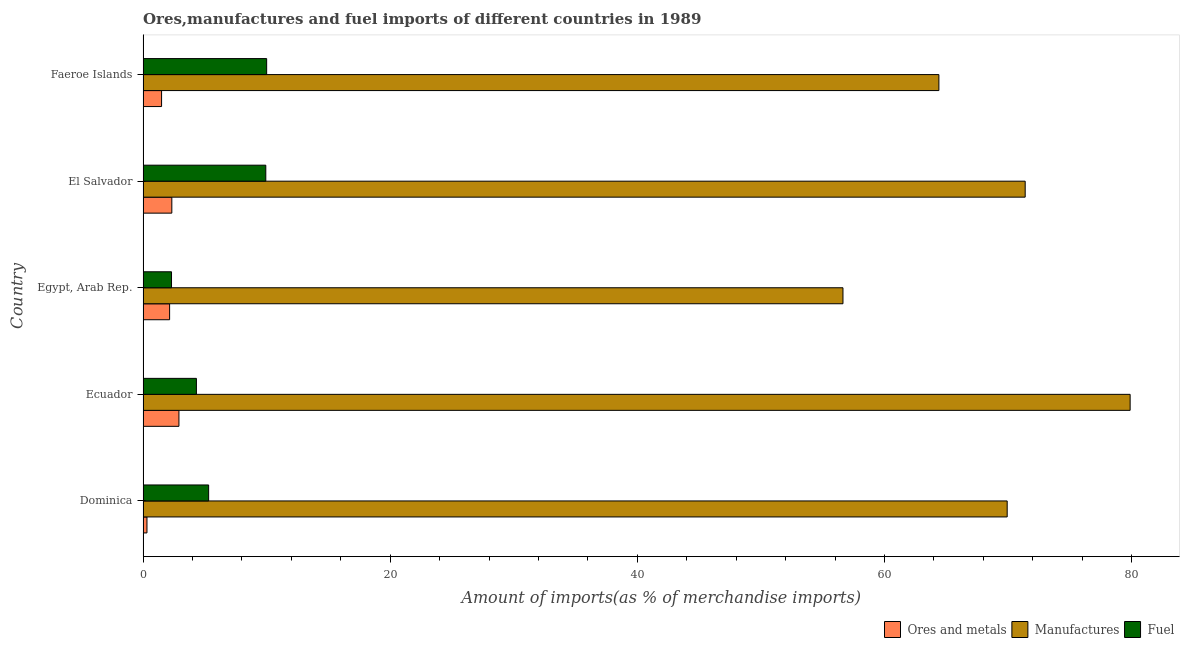Are the number of bars on each tick of the Y-axis equal?
Provide a short and direct response. Yes. How many bars are there on the 5th tick from the bottom?
Keep it short and to the point. 3. What is the label of the 2nd group of bars from the top?
Your answer should be compact. El Salvador. What is the percentage of fuel imports in Dominica?
Offer a terse response. 5.31. Across all countries, what is the maximum percentage of manufactures imports?
Provide a short and direct response. 79.88. Across all countries, what is the minimum percentage of ores and metals imports?
Provide a succinct answer. 0.32. In which country was the percentage of manufactures imports maximum?
Offer a very short reply. Ecuador. In which country was the percentage of ores and metals imports minimum?
Make the answer very short. Dominica. What is the total percentage of fuel imports in the graph?
Offer a terse response. 31.86. What is the difference between the percentage of fuel imports in El Salvador and that in Faeroe Islands?
Your response must be concise. -0.07. What is the difference between the percentage of fuel imports in Ecuador and the percentage of ores and metals imports in Dominica?
Ensure brevity in your answer.  4. What is the average percentage of fuel imports per country?
Your answer should be compact. 6.37. What is the difference between the percentage of ores and metals imports and percentage of fuel imports in Ecuador?
Provide a short and direct response. -1.42. What is the ratio of the percentage of manufactures imports in Dominica to that in Egypt, Arab Rep.?
Ensure brevity in your answer.  1.24. What is the difference between the highest and the second highest percentage of ores and metals imports?
Your answer should be very brief. 0.57. What is the difference between the highest and the lowest percentage of manufactures imports?
Provide a short and direct response. 23.24. What does the 1st bar from the top in El Salvador represents?
Provide a short and direct response. Fuel. What does the 1st bar from the bottom in El Salvador represents?
Offer a very short reply. Ores and metals. Is it the case that in every country, the sum of the percentage of ores and metals imports and percentage of manufactures imports is greater than the percentage of fuel imports?
Ensure brevity in your answer.  Yes. Are all the bars in the graph horizontal?
Offer a very short reply. Yes. How many countries are there in the graph?
Provide a short and direct response. 5. Are the values on the major ticks of X-axis written in scientific E-notation?
Keep it short and to the point. No. Where does the legend appear in the graph?
Your answer should be compact. Bottom right. What is the title of the graph?
Make the answer very short. Ores,manufactures and fuel imports of different countries in 1989. Does "Total employers" appear as one of the legend labels in the graph?
Make the answer very short. No. What is the label or title of the X-axis?
Offer a terse response. Amount of imports(as % of merchandise imports). What is the Amount of imports(as % of merchandise imports) of Ores and metals in Dominica?
Ensure brevity in your answer.  0.32. What is the Amount of imports(as % of merchandise imports) in Manufactures in Dominica?
Your answer should be compact. 69.93. What is the Amount of imports(as % of merchandise imports) in Fuel in Dominica?
Ensure brevity in your answer.  5.31. What is the Amount of imports(as % of merchandise imports) in Ores and metals in Ecuador?
Keep it short and to the point. 2.9. What is the Amount of imports(as % of merchandise imports) in Manufactures in Ecuador?
Your answer should be very brief. 79.88. What is the Amount of imports(as % of merchandise imports) of Fuel in Ecuador?
Your response must be concise. 4.32. What is the Amount of imports(as % of merchandise imports) in Ores and metals in Egypt, Arab Rep.?
Ensure brevity in your answer.  2.15. What is the Amount of imports(as % of merchandise imports) in Manufactures in Egypt, Arab Rep.?
Ensure brevity in your answer.  56.64. What is the Amount of imports(as % of merchandise imports) in Fuel in Egypt, Arab Rep.?
Give a very brief answer. 2.3. What is the Amount of imports(as % of merchandise imports) in Ores and metals in El Salvador?
Keep it short and to the point. 2.33. What is the Amount of imports(as % of merchandise imports) of Manufactures in El Salvador?
Your response must be concise. 71.39. What is the Amount of imports(as % of merchandise imports) of Fuel in El Salvador?
Your answer should be compact. 9.93. What is the Amount of imports(as % of merchandise imports) in Ores and metals in Faeroe Islands?
Make the answer very short. 1.5. What is the Amount of imports(as % of merchandise imports) of Manufactures in Faeroe Islands?
Offer a terse response. 64.41. What is the Amount of imports(as % of merchandise imports) of Fuel in Faeroe Islands?
Provide a short and direct response. 10. Across all countries, what is the maximum Amount of imports(as % of merchandise imports) of Ores and metals?
Your response must be concise. 2.9. Across all countries, what is the maximum Amount of imports(as % of merchandise imports) in Manufactures?
Your response must be concise. 79.88. Across all countries, what is the maximum Amount of imports(as % of merchandise imports) of Fuel?
Offer a very short reply. 10. Across all countries, what is the minimum Amount of imports(as % of merchandise imports) of Ores and metals?
Ensure brevity in your answer.  0.32. Across all countries, what is the minimum Amount of imports(as % of merchandise imports) of Manufactures?
Your answer should be very brief. 56.64. Across all countries, what is the minimum Amount of imports(as % of merchandise imports) in Fuel?
Make the answer very short. 2.3. What is the total Amount of imports(as % of merchandise imports) of Ores and metals in the graph?
Your answer should be compact. 9.19. What is the total Amount of imports(as % of merchandise imports) in Manufactures in the graph?
Offer a terse response. 342.26. What is the total Amount of imports(as % of merchandise imports) of Fuel in the graph?
Give a very brief answer. 31.86. What is the difference between the Amount of imports(as % of merchandise imports) of Ores and metals in Dominica and that in Ecuador?
Your answer should be compact. -2.59. What is the difference between the Amount of imports(as % of merchandise imports) in Manufactures in Dominica and that in Ecuador?
Your answer should be very brief. -9.95. What is the difference between the Amount of imports(as % of merchandise imports) in Ores and metals in Dominica and that in Egypt, Arab Rep.?
Your answer should be compact. -1.83. What is the difference between the Amount of imports(as % of merchandise imports) of Manufactures in Dominica and that in Egypt, Arab Rep.?
Give a very brief answer. 13.29. What is the difference between the Amount of imports(as % of merchandise imports) in Fuel in Dominica and that in Egypt, Arab Rep.?
Provide a short and direct response. 3.01. What is the difference between the Amount of imports(as % of merchandise imports) of Ores and metals in Dominica and that in El Salvador?
Offer a very short reply. -2.01. What is the difference between the Amount of imports(as % of merchandise imports) of Manufactures in Dominica and that in El Salvador?
Make the answer very short. -1.46. What is the difference between the Amount of imports(as % of merchandise imports) of Fuel in Dominica and that in El Salvador?
Your response must be concise. -4.63. What is the difference between the Amount of imports(as % of merchandise imports) of Ores and metals in Dominica and that in Faeroe Islands?
Keep it short and to the point. -1.18. What is the difference between the Amount of imports(as % of merchandise imports) of Manufactures in Dominica and that in Faeroe Islands?
Offer a terse response. 5.53. What is the difference between the Amount of imports(as % of merchandise imports) of Fuel in Dominica and that in Faeroe Islands?
Your answer should be compact. -4.7. What is the difference between the Amount of imports(as % of merchandise imports) in Ores and metals in Ecuador and that in Egypt, Arab Rep.?
Offer a terse response. 0.75. What is the difference between the Amount of imports(as % of merchandise imports) in Manufactures in Ecuador and that in Egypt, Arab Rep.?
Your response must be concise. 23.24. What is the difference between the Amount of imports(as % of merchandise imports) in Fuel in Ecuador and that in Egypt, Arab Rep.?
Your answer should be very brief. 2.02. What is the difference between the Amount of imports(as % of merchandise imports) in Ores and metals in Ecuador and that in El Salvador?
Offer a very short reply. 0.57. What is the difference between the Amount of imports(as % of merchandise imports) of Manufactures in Ecuador and that in El Salvador?
Your answer should be very brief. 8.49. What is the difference between the Amount of imports(as % of merchandise imports) of Fuel in Ecuador and that in El Salvador?
Offer a terse response. -5.62. What is the difference between the Amount of imports(as % of merchandise imports) in Ores and metals in Ecuador and that in Faeroe Islands?
Keep it short and to the point. 1.4. What is the difference between the Amount of imports(as % of merchandise imports) of Manufactures in Ecuador and that in Faeroe Islands?
Your response must be concise. 15.48. What is the difference between the Amount of imports(as % of merchandise imports) in Fuel in Ecuador and that in Faeroe Islands?
Provide a succinct answer. -5.69. What is the difference between the Amount of imports(as % of merchandise imports) in Ores and metals in Egypt, Arab Rep. and that in El Salvador?
Offer a terse response. -0.18. What is the difference between the Amount of imports(as % of merchandise imports) of Manufactures in Egypt, Arab Rep. and that in El Salvador?
Your response must be concise. -14.75. What is the difference between the Amount of imports(as % of merchandise imports) of Fuel in Egypt, Arab Rep. and that in El Salvador?
Provide a short and direct response. -7.63. What is the difference between the Amount of imports(as % of merchandise imports) of Ores and metals in Egypt, Arab Rep. and that in Faeroe Islands?
Keep it short and to the point. 0.65. What is the difference between the Amount of imports(as % of merchandise imports) in Manufactures in Egypt, Arab Rep. and that in Faeroe Islands?
Make the answer very short. -7.76. What is the difference between the Amount of imports(as % of merchandise imports) of Fuel in Egypt, Arab Rep. and that in Faeroe Islands?
Your answer should be compact. -7.7. What is the difference between the Amount of imports(as % of merchandise imports) in Ores and metals in El Salvador and that in Faeroe Islands?
Provide a succinct answer. 0.83. What is the difference between the Amount of imports(as % of merchandise imports) in Manufactures in El Salvador and that in Faeroe Islands?
Provide a succinct answer. 6.98. What is the difference between the Amount of imports(as % of merchandise imports) of Fuel in El Salvador and that in Faeroe Islands?
Keep it short and to the point. -0.07. What is the difference between the Amount of imports(as % of merchandise imports) of Ores and metals in Dominica and the Amount of imports(as % of merchandise imports) of Manufactures in Ecuador?
Keep it short and to the point. -79.57. What is the difference between the Amount of imports(as % of merchandise imports) of Ores and metals in Dominica and the Amount of imports(as % of merchandise imports) of Fuel in Ecuador?
Offer a terse response. -4. What is the difference between the Amount of imports(as % of merchandise imports) of Manufactures in Dominica and the Amount of imports(as % of merchandise imports) of Fuel in Ecuador?
Keep it short and to the point. 65.62. What is the difference between the Amount of imports(as % of merchandise imports) of Ores and metals in Dominica and the Amount of imports(as % of merchandise imports) of Manufactures in Egypt, Arab Rep.?
Keep it short and to the point. -56.33. What is the difference between the Amount of imports(as % of merchandise imports) of Ores and metals in Dominica and the Amount of imports(as % of merchandise imports) of Fuel in Egypt, Arab Rep.?
Offer a very short reply. -1.99. What is the difference between the Amount of imports(as % of merchandise imports) in Manufactures in Dominica and the Amount of imports(as % of merchandise imports) in Fuel in Egypt, Arab Rep.?
Provide a succinct answer. 67.63. What is the difference between the Amount of imports(as % of merchandise imports) of Ores and metals in Dominica and the Amount of imports(as % of merchandise imports) of Manufactures in El Salvador?
Offer a terse response. -71.07. What is the difference between the Amount of imports(as % of merchandise imports) in Ores and metals in Dominica and the Amount of imports(as % of merchandise imports) in Fuel in El Salvador?
Ensure brevity in your answer.  -9.62. What is the difference between the Amount of imports(as % of merchandise imports) of Manufactures in Dominica and the Amount of imports(as % of merchandise imports) of Fuel in El Salvador?
Give a very brief answer. 60. What is the difference between the Amount of imports(as % of merchandise imports) in Ores and metals in Dominica and the Amount of imports(as % of merchandise imports) in Manufactures in Faeroe Islands?
Give a very brief answer. -64.09. What is the difference between the Amount of imports(as % of merchandise imports) of Ores and metals in Dominica and the Amount of imports(as % of merchandise imports) of Fuel in Faeroe Islands?
Your answer should be very brief. -9.69. What is the difference between the Amount of imports(as % of merchandise imports) of Manufactures in Dominica and the Amount of imports(as % of merchandise imports) of Fuel in Faeroe Islands?
Give a very brief answer. 59.93. What is the difference between the Amount of imports(as % of merchandise imports) of Ores and metals in Ecuador and the Amount of imports(as % of merchandise imports) of Manufactures in Egypt, Arab Rep.?
Keep it short and to the point. -53.74. What is the difference between the Amount of imports(as % of merchandise imports) of Ores and metals in Ecuador and the Amount of imports(as % of merchandise imports) of Fuel in Egypt, Arab Rep.?
Keep it short and to the point. 0.6. What is the difference between the Amount of imports(as % of merchandise imports) in Manufactures in Ecuador and the Amount of imports(as % of merchandise imports) in Fuel in Egypt, Arab Rep.?
Give a very brief answer. 77.58. What is the difference between the Amount of imports(as % of merchandise imports) in Ores and metals in Ecuador and the Amount of imports(as % of merchandise imports) in Manufactures in El Salvador?
Offer a terse response. -68.49. What is the difference between the Amount of imports(as % of merchandise imports) in Ores and metals in Ecuador and the Amount of imports(as % of merchandise imports) in Fuel in El Salvador?
Offer a very short reply. -7.03. What is the difference between the Amount of imports(as % of merchandise imports) of Manufactures in Ecuador and the Amount of imports(as % of merchandise imports) of Fuel in El Salvador?
Your answer should be very brief. 69.95. What is the difference between the Amount of imports(as % of merchandise imports) of Ores and metals in Ecuador and the Amount of imports(as % of merchandise imports) of Manufactures in Faeroe Islands?
Your answer should be very brief. -61.5. What is the difference between the Amount of imports(as % of merchandise imports) of Ores and metals in Ecuador and the Amount of imports(as % of merchandise imports) of Fuel in Faeroe Islands?
Your response must be concise. -7.1. What is the difference between the Amount of imports(as % of merchandise imports) in Manufactures in Ecuador and the Amount of imports(as % of merchandise imports) in Fuel in Faeroe Islands?
Make the answer very short. 69.88. What is the difference between the Amount of imports(as % of merchandise imports) of Ores and metals in Egypt, Arab Rep. and the Amount of imports(as % of merchandise imports) of Manufactures in El Salvador?
Your answer should be very brief. -69.24. What is the difference between the Amount of imports(as % of merchandise imports) of Ores and metals in Egypt, Arab Rep. and the Amount of imports(as % of merchandise imports) of Fuel in El Salvador?
Give a very brief answer. -7.78. What is the difference between the Amount of imports(as % of merchandise imports) in Manufactures in Egypt, Arab Rep. and the Amount of imports(as % of merchandise imports) in Fuel in El Salvador?
Provide a short and direct response. 46.71. What is the difference between the Amount of imports(as % of merchandise imports) of Ores and metals in Egypt, Arab Rep. and the Amount of imports(as % of merchandise imports) of Manufactures in Faeroe Islands?
Offer a very short reply. -62.26. What is the difference between the Amount of imports(as % of merchandise imports) in Ores and metals in Egypt, Arab Rep. and the Amount of imports(as % of merchandise imports) in Fuel in Faeroe Islands?
Offer a terse response. -7.85. What is the difference between the Amount of imports(as % of merchandise imports) in Manufactures in Egypt, Arab Rep. and the Amount of imports(as % of merchandise imports) in Fuel in Faeroe Islands?
Offer a terse response. 46.64. What is the difference between the Amount of imports(as % of merchandise imports) in Ores and metals in El Salvador and the Amount of imports(as % of merchandise imports) in Manufactures in Faeroe Islands?
Your response must be concise. -62.08. What is the difference between the Amount of imports(as % of merchandise imports) of Ores and metals in El Salvador and the Amount of imports(as % of merchandise imports) of Fuel in Faeroe Islands?
Make the answer very short. -7.67. What is the difference between the Amount of imports(as % of merchandise imports) of Manufactures in El Salvador and the Amount of imports(as % of merchandise imports) of Fuel in Faeroe Islands?
Your answer should be very brief. 61.39. What is the average Amount of imports(as % of merchandise imports) in Ores and metals per country?
Your response must be concise. 1.84. What is the average Amount of imports(as % of merchandise imports) of Manufactures per country?
Your response must be concise. 68.45. What is the average Amount of imports(as % of merchandise imports) in Fuel per country?
Provide a succinct answer. 6.37. What is the difference between the Amount of imports(as % of merchandise imports) in Ores and metals and Amount of imports(as % of merchandise imports) in Manufactures in Dominica?
Provide a short and direct response. -69.62. What is the difference between the Amount of imports(as % of merchandise imports) in Ores and metals and Amount of imports(as % of merchandise imports) in Fuel in Dominica?
Offer a very short reply. -4.99. What is the difference between the Amount of imports(as % of merchandise imports) in Manufactures and Amount of imports(as % of merchandise imports) in Fuel in Dominica?
Ensure brevity in your answer.  64.63. What is the difference between the Amount of imports(as % of merchandise imports) of Ores and metals and Amount of imports(as % of merchandise imports) of Manufactures in Ecuador?
Ensure brevity in your answer.  -76.98. What is the difference between the Amount of imports(as % of merchandise imports) of Ores and metals and Amount of imports(as % of merchandise imports) of Fuel in Ecuador?
Provide a short and direct response. -1.41. What is the difference between the Amount of imports(as % of merchandise imports) of Manufactures and Amount of imports(as % of merchandise imports) of Fuel in Ecuador?
Keep it short and to the point. 75.57. What is the difference between the Amount of imports(as % of merchandise imports) in Ores and metals and Amount of imports(as % of merchandise imports) in Manufactures in Egypt, Arab Rep.?
Ensure brevity in your answer.  -54.49. What is the difference between the Amount of imports(as % of merchandise imports) in Ores and metals and Amount of imports(as % of merchandise imports) in Fuel in Egypt, Arab Rep.?
Provide a short and direct response. -0.15. What is the difference between the Amount of imports(as % of merchandise imports) in Manufactures and Amount of imports(as % of merchandise imports) in Fuel in Egypt, Arab Rep.?
Ensure brevity in your answer.  54.34. What is the difference between the Amount of imports(as % of merchandise imports) of Ores and metals and Amount of imports(as % of merchandise imports) of Manufactures in El Salvador?
Your response must be concise. -69.06. What is the difference between the Amount of imports(as % of merchandise imports) in Ores and metals and Amount of imports(as % of merchandise imports) in Fuel in El Salvador?
Offer a very short reply. -7.6. What is the difference between the Amount of imports(as % of merchandise imports) of Manufactures and Amount of imports(as % of merchandise imports) of Fuel in El Salvador?
Offer a very short reply. 61.46. What is the difference between the Amount of imports(as % of merchandise imports) in Ores and metals and Amount of imports(as % of merchandise imports) in Manufactures in Faeroe Islands?
Offer a terse response. -62.91. What is the difference between the Amount of imports(as % of merchandise imports) of Ores and metals and Amount of imports(as % of merchandise imports) of Fuel in Faeroe Islands?
Keep it short and to the point. -8.5. What is the difference between the Amount of imports(as % of merchandise imports) in Manufactures and Amount of imports(as % of merchandise imports) in Fuel in Faeroe Islands?
Offer a terse response. 54.4. What is the ratio of the Amount of imports(as % of merchandise imports) in Ores and metals in Dominica to that in Ecuador?
Your answer should be very brief. 0.11. What is the ratio of the Amount of imports(as % of merchandise imports) in Manufactures in Dominica to that in Ecuador?
Offer a very short reply. 0.88. What is the ratio of the Amount of imports(as % of merchandise imports) of Fuel in Dominica to that in Ecuador?
Ensure brevity in your answer.  1.23. What is the ratio of the Amount of imports(as % of merchandise imports) of Ores and metals in Dominica to that in Egypt, Arab Rep.?
Give a very brief answer. 0.15. What is the ratio of the Amount of imports(as % of merchandise imports) in Manufactures in Dominica to that in Egypt, Arab Rep.?
Give a very brief answer. 1.23. What is the ratio of the Amount of imports(as % of merchandise imports) of Fuel in Dominica to that in Egypt, Arab Rep.?
Provide a short and direct response. 2.31. What is the ratio of the Amount of imports(as % of merchandise imports) in Ores and metals in Dominica to that in El Salvador?
Make the answer very short. 0.14. What is the ratio of the Amount of imports(as % of merchandise imports) in Manufactures in Dominica to that in El Salvador?
Your response must be concise. 0.98. What is the ratio of the Amount of imports(as % of merchandise imports) in Fuel in Dominica to that in El Salvador?
Provide a short and direct response. 0.53. What is the ratio of the Amount of imports(as % of merchandise imports) of Ores and metals in Dominica to that in Faeroe Islands?
Offer a very short reply. 0.21. What is the ratio of the Amount of imports(as % of merchandise imports) of Manufactures in Dominica to that in Faeroe Islands?
Provide a short and direct response. 1.09. What is the ratio of the Amount of imports(as % of merchandise imports) in Fuel in Dominica to that in Faeroe Islands?
Give a very brief answer. 0.53. What is the ratio of the Amount of imports(as % of merchandise imports) of Ores and metals in Ecuador to that in Egypt, Arab Rep.?
Your answer should be very brief. 1.35. What is the ratio of the Amount of imports(as % of merchandise imports) of Manufactures in Ecuador to that in Egypt, Arab Rep.?
Provide a short and direct response. 1.41. What is the ratio of the Amount of imports(as % of merchandise imports) in Fuel in Ecuador to that in Egypt, Arab Rep.?
Your response must be concise. 1.88. What is the ratio of the Amount of imports(as % of merchandise imports) of Ores and metals in Ecuador to that in El Salvador?
Offer a very short reply. 1.25. What is the ratio of the Amount of imports(as % of merchandise imports) of Manufactures in Ecuador to that in El Salvador?
Give a very brief answer. 1.12. What is the ratio of the Amount of imports(as % of merchandise imports) in Fuel in Ecuador to that in El Salvador?
Provide a short and direct response. 0.43. What is the ratio of the Amount of imports(as % of merchandise imports) in Ores and metals in Ecuador to that in Faeroe Islands?
Your response must be concise. 1.94. What is the ratio of the Amount of imports(as % of merchandise imports) in Manufactures in Ecuador to that in Faeroe Islands?
Keep it short and to the point. 1.24. What is the ratio of the Amount of imports(as % of merchandise imports) in Fuel in Ecuador to that in Faeroe Islands?
Give a very brief answer. 0.43. What is the ratio of the Amount of imports(as % of merchandise imports) of Ores and metals in Egypt, Arab Rep. to that in El Salvador?
Your answer should be compact. 0.92. What is the ratio of the Amount of imports(as % of merchandise imports) of Manufactures in Egypt, Arab Rep. to that in El Salvador?
Give a very brief answer. 0.79. What is the ratio of the Amount of imports(as % of merchandise imports) of Fuel in Egypt, Arab Rep. to that in El Salvador?
Your answer should be compact. 0.23. What is the ratio of the Amount of imports(as % of merchandise imports) of Ores and metals in Egypt, Arab Rep. to that in Faeroe Islands?
Give a very brief answer. 1.43. What is the ratio of the Amount of imports(as % of merchandise imports) in Manufactures in Egypt, Arab Rep. to that in Faeroe Islands?
Offer a very short reply. 0.88. What is the ratio of the Amount of imports(as % of merchandise imports) of Fuel in Egypt, Arab Rep. to that in Faeroe Islands?
Your answer should be compact. 0.23. What is the ratio of the Amount of imports(as % of merchandise imports) of Ores and metals in El Salvador to that in Faeroe Islands?
Provide a succinct answer. 1.55. What is the ratio of the Amount of imports(as % of merchandise imports) in Manufactures in El Salvador to that in Faeroe Islands?
Offer a terse response. 1.11. What is the ratio of the Amount of imports(as % of merchandise imports) of Fuel in El Salvador to that in Faeroe Islands?
Offer a very short reply. 0.99. What is the difference between the highest and the second highest Amount of imports(as % of merchandise imports) of Ores and metals?
Your answer should be very brief. 0.57. What is the difference between the highest and the second highest Amount of imports(as % of merchandise imports) in Manufactures?
Provide a succinct answer. 8.49. What is the difference between the highest and the second highest Amount of imports(as % of merchandise imports) in Fuel?
Offer a terse response. 0.07. What is the difference between the highest and the lowest Amount of imports(as % of merchandise imports) of Ores and metals?
Give a very brief answer. 2.59. What is the difference between the highest and the lowest Amount of imports(as % of merchandise imports) in Manufactures?
Your response must be concise. 23.24. What is the difference between the highest and the lowest Amount of imports(as % of merchandise imports) of Fuel?
Provide a succinct answer. 7.7. 